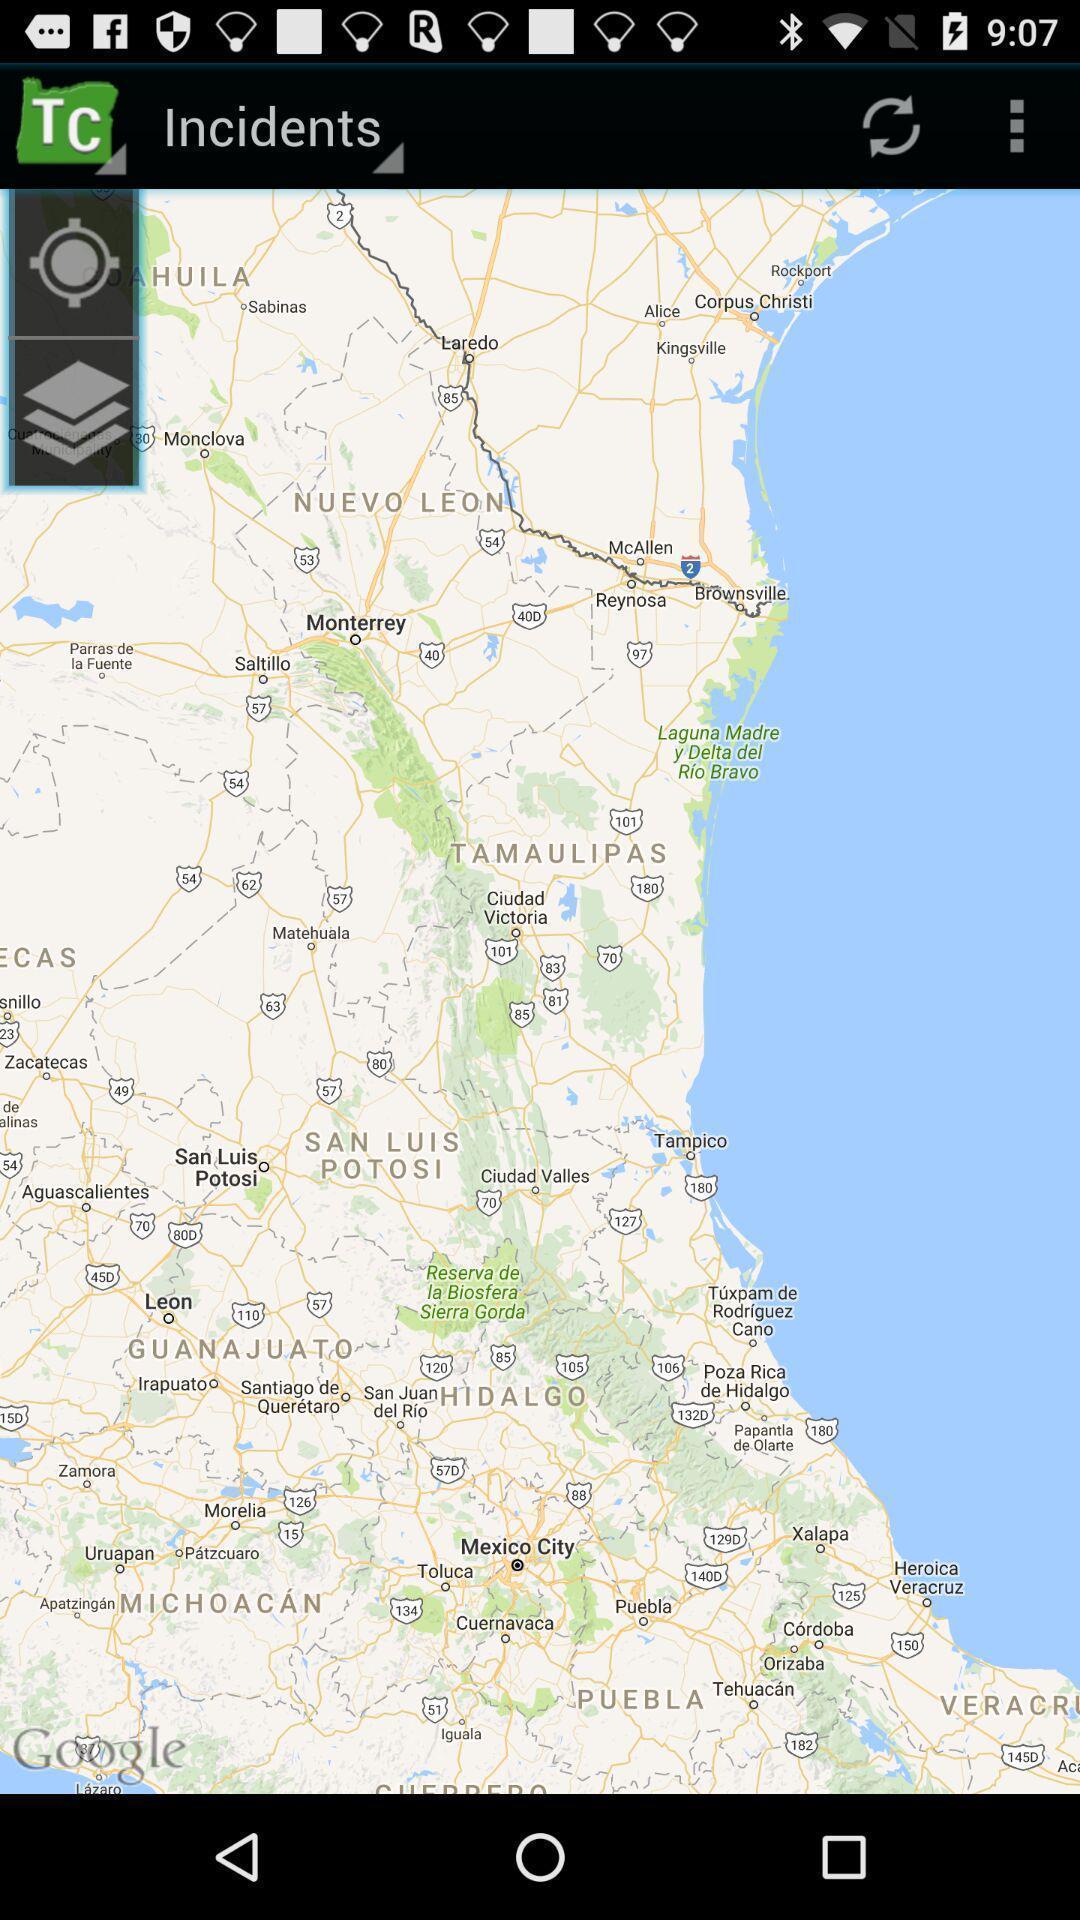Describe the key features of this screenshot. Screen showing incidents page. 